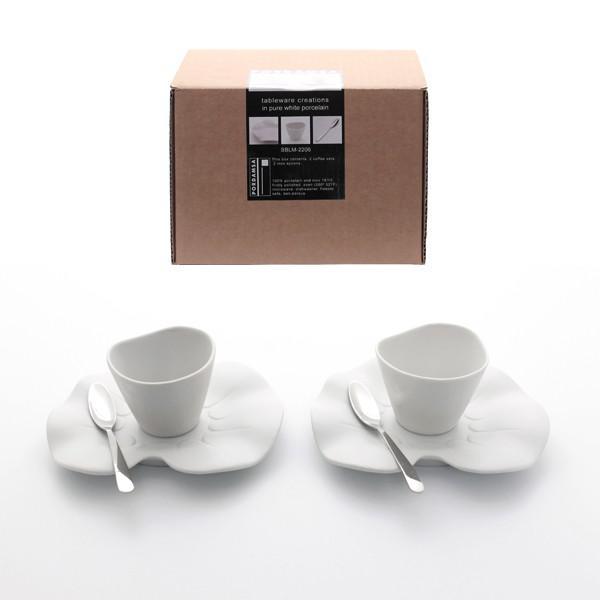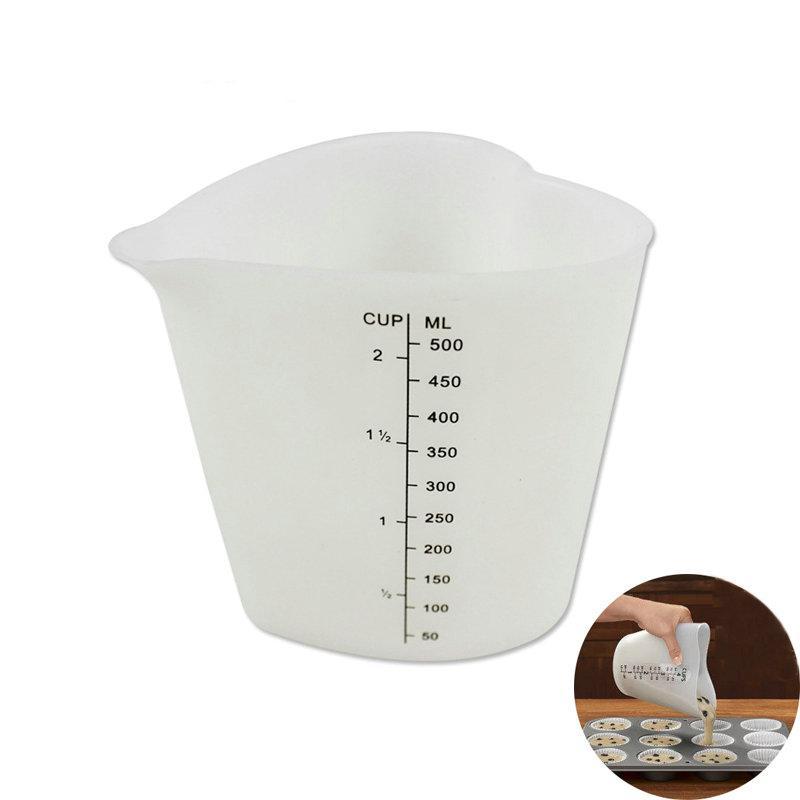The first image is the image on the left, the second image is the image on the right. Assess this claim about the two images: "The left image depicts exactly one spoon next to one container.". Correct or not? Answer yes or no. No. 